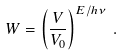Convert formula to latex. <formula><loc_0><loc_0><loc_500><loc_500>W = \left ( \frac { V } { V _ { 0 } } \right ) ^ { E / h \nu } \, .</formula> 